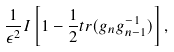<formula> <loc_0><loc_0><loc_500><loc_500>\frac { 1 } { \epsilon ^ { 2 } } I \left [ 1 - \frac { 1 } { 2 } t r ( g _ { n } g _ { n - 1 } ^ { - 1 } ) \right ] ,</formula> 